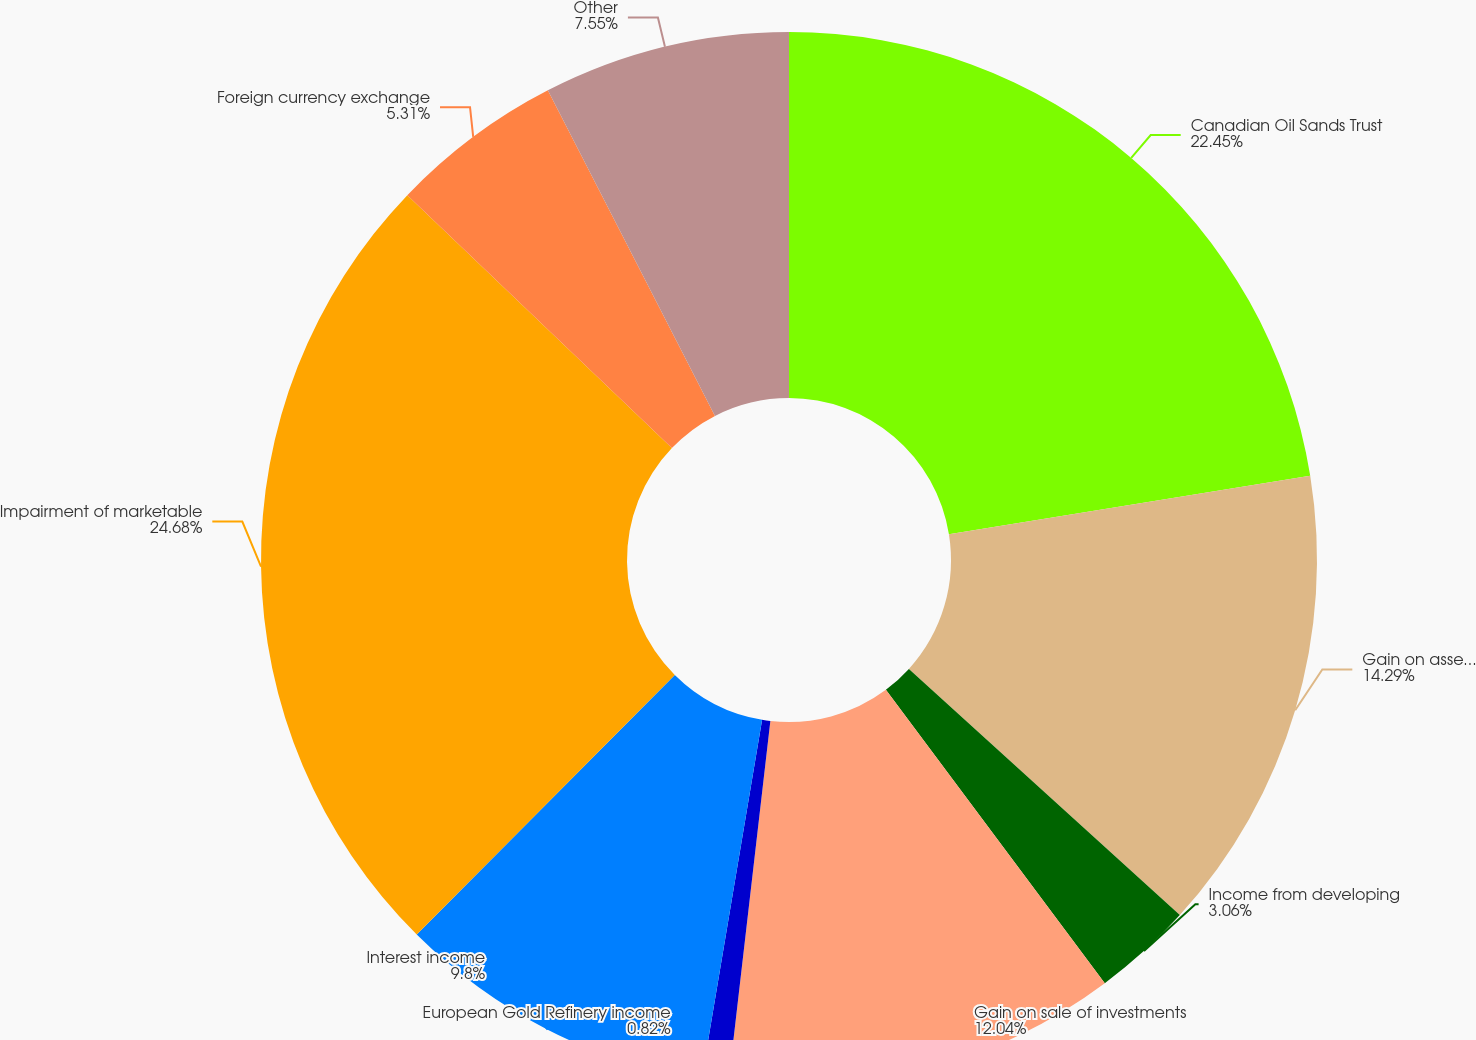Convert chart. <chart><loc_0><loc_0><loc_500><loc_500><pie_chart><fcel>Canadian Oil Sands Trust<fcel>Gain on asset sales net<fcel>Income from developing<fcel>Gain on sale of investments<fcel>European Gold Refinery income<fcel>Interest income<fcel>Impairment of marketable<fcel>Foreign currency exchange<fcel>Other<nl><fcel>22.45%<fcel>14.29%<fcel>3.06%<fcel>12.04%<fcel>0.82%<fcel>9.8%<fcel>24.69%<fcel>5.31%<fcel>7.55%<nl></chart> 